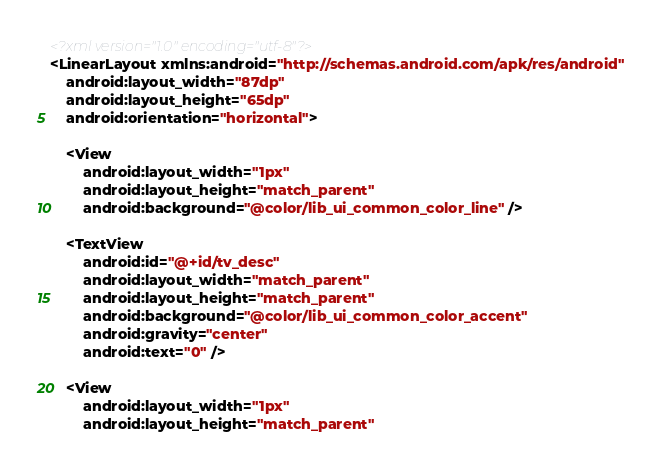<code> <loc_0><loc_0><loc_500><loc_500><_XML_><?xml version="1.0" encoding="utf-8"?>
<LinearLayout xmlns:android="http://schemas.android.com/apk/res/android"
    android:layout_width="87dp"
    android:layout_height="65dp"
    android:orientation="horizontal">

    <View
        android:layout_width="1px"
        android:layout_height="match_parent"
        android:background="@color/lib_ui_common_color_line" />

    <TextView
        android:id="@+id/tv_desc"
        android:layout_width="match_parent"
        android:layout_height="match_parent"
        android:background="@color/lib_ui_common_color_accent"
        android:gravity="center"
        android:text="0" />

    <View
        android:layout_width="1px"
        android:layout_height="match_parent"</code> 